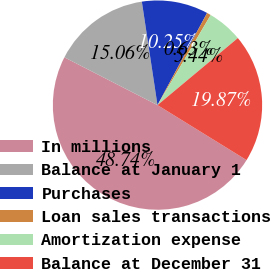Convert chart to OTSL. <chart><loc_0><loc_0><loc_500><loc_500><pie_chart><fcel>In millions<fcel>Balance at January 1<fcel>Purchases<fcel>Loan sales transactions<fcel>Amortization expense<fcel>Balance at December 31<nl><fcel>48.74%<fcel>15.06%<fcel>10.25%<fcel>0.63%<fcel>5.44%<fcel>19.87%<nl></chart> 